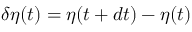<formula> <loc_0><loc_0><loc_500><loc_500>\delta \eta ( t ) = \eta ( t + d t ) - \eta ( t )</formula> 